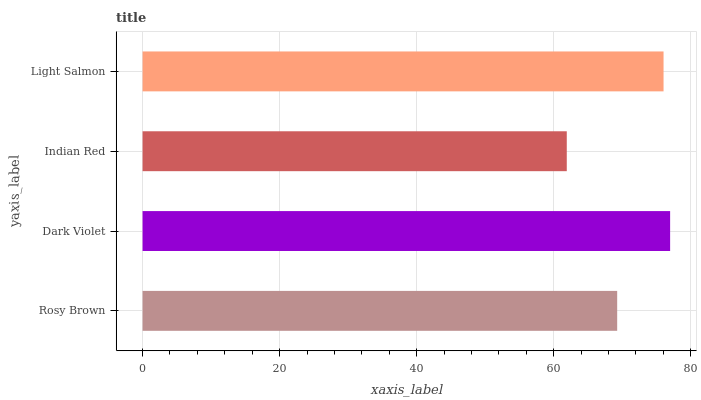Is Indian Red the minimum?
Answer yes or no. Yes. Is Dark Violet the maximum?
Answer yes or no. Yes. Is Dark Violet the minimum?
Answer yes or no. No. Is Indian Red the maximum?
Answer yes or no. No. Is Dark Violet greater than Indian Red?
Answer yes or no. Yes. Is Indian Red less than Dark Violet?
Answer yes or no. Yes. Is Indian Red greater than Dark Violet?
Answer yes or no. No. Is Dark Violet less than Indian Red?
Answer yes or no. No. Is Light Salmon the high median?
Answer yes or no. Yes. Is Rosy Brown the low median?
Answer yes or no. Yes. Is Rosy Brown the high median?
Answer yes or no. No. Is Dark Violet the low median?
Answer yes or no. No. 